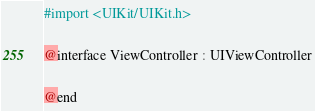Convert code to text. <code><loc_0><loc_0><loc_500><loc_500><_C_>#import <UIKit/UIKit.h>

@interface ViewController : UIViewController

@end
</code> 